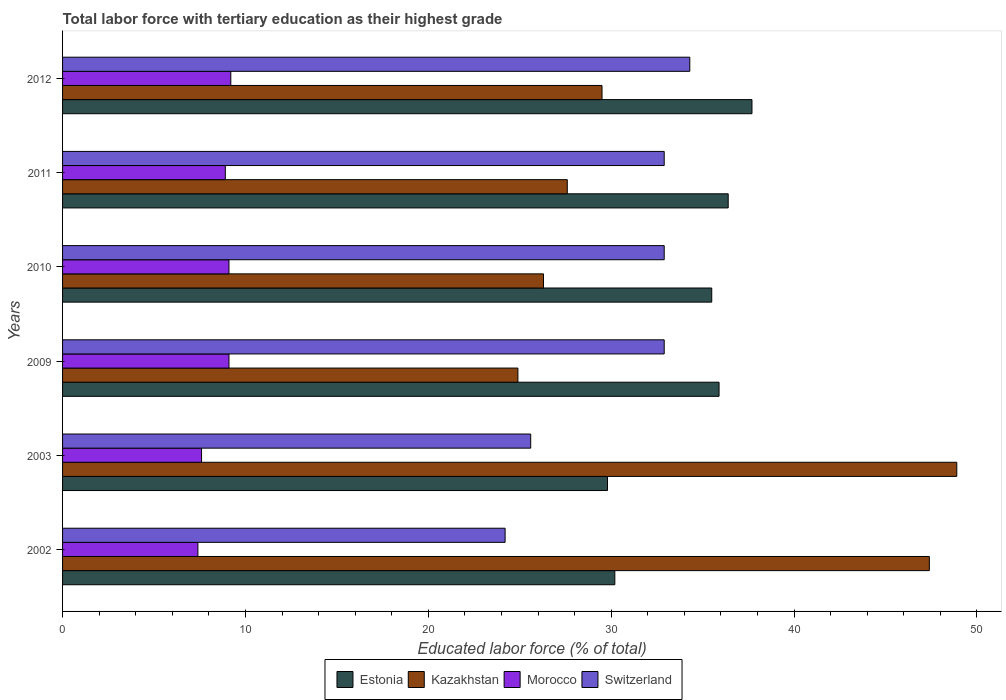Are the number of bars per tick equal to the number of legend labels?
Your answer should be very brief. Yes. How many bars are there on the 6th tick from the bottom?
Provide a short and direct response. 4. In how many cases, is the number of bars for a given year not equal to the number of legend labels?
Provide a succinct answer. 0. What is the percentage of male labor force with tertiary education in Estonia in 2012?
Provide a short and direct response. 37.7. Across all years, what is the maximum percentage of male labor force with tertiary education in Kazakhstan?
Your answer should be very brief. 48.9. Across all years, what is the minimum percentage of male labor force with tertiary education in Estonia?
Make the answer very short. 29.8. In which year was the percentage of male labor force with tertiary education in Switzerland maximum?
Provide a short and direct response. 2012. In which year was the percentage of male labor force with tertiary education in Estonia minimum?
Your answer should be very brief. 2003. What is the total percentage of male labor force with tertiary education in Morocco in the graph?
Offer a terse response. 51.3. What is the difference between the percentage of male labor force with tertiary education in Morocco in 2002 and that in 2009?
Your response must be concise. -1.7. What is the difference between the percentage of male labor force with tertiary education in Switzerland in 2009 and the percentage of male labor force with tertiary education in Morocco in 2012?
Ensure brevity in your answer.  23.7. What is the average percentage of male labor force with tertiary education in Morocco per year?
Keep it short and to the point. 8.55. In the year 2010, what is the difference between the percentage of male labor force with tertiary education in Estonia and percentage of male labor force with tertiary education in Kazakhstan?
Offer a terse response. 9.2. What is the ratio of the percentage of male labor force with tertiary education in Morocco in 2009 to that in 2011?
Keep it short and to the point. 1.02. What is the difference between the highest and the second highest percentage of male labor force with tertiary education in Switzerland?
Provide a succinct answer. 1.4. What is the difference between the highest and the lowest percentage of male labor force with tertiary education in Estonia?
Provide a short and direct response. 7.9. In how many years, is the percentage of male labor force with tertiary education in Switzerland greater than the average percentage of male labor force with tertiary education in Switzerland taken over all years?
Give a very brief answer. 4. What does the 3rd bar from the top in 2002 represents?
Make the answer very short. Kazakhstan. What does the 4th bar from the bottom in 2012 represents?
Give a very brief answer. Switzerland. How many bars are there?
Keep it short and to the point. 24. Are all the bars in the graph horizontal?
Give a very brief answer. Yes. What is the difference between two consecutive major ticks on the X-axis?
Offer a very short reply. 10. Are the values on the major ticks of X-axis written in scientific E-notation?
Provide a succinct answer. No. Does the graph contain grids?
Keep it short and to the point. No. How are the legend labels stacked?
Make the answer very short. Horizontal. What is the title of the graph?
Offer a terse response. Total labor force with tertiary education as their highest grade. What is the label or title of the X-axis?
Keep it short and to the point. Educated labor force (% of total). What is the label or title of the Y-axis?
Make the answer very short. Years. What is the Educated labor force (% of total) in Estonia in 2002?
Offer a terse response. 30.2. What is the Educated labor force (% of total) in Kazakhstan in 2002?
Your answer should be very brief. 47.4. What is the Educated labor force (% of total) in Morocco in 2002?
Provide a succinct answer. 7.4. What is the Educated labor force (% of total) of Switzerland in 2002?
Make the answer very short. 24.2. What is the Educated labor force (% of total) in Estonia in 2003?
Give a very brief answer. 29.8. What is the Educated labor force (% of total) of Kazakhstan in 2003?
Give a very brief answer. 48.9. What is the Educated labor force (% of total) of Morocco in 2003?
Make the answer very short. 7.6. What is the Educated labor force (% of total) of Switzerland in 2003?
Ensure brevity in your answer.  25.6. What is the Educated labor force (% of total) of Estonia in 2009?
Provide a succinct answer. 35.9. What is the Educated labor force (% of total) in Kazakhstan in 2009?
Provide a short and direct response. 24.9. What is the Educated labor force (% of total) in Morocco in 2009?
Give a very brief answer. 9.1. What is the Educated labor force (% of total) in Switzerland in 2009?
Give a very brief answer. 32.9. What is the Educated labor force (% of total) in Estonia in 2010?
Give a very brief answer. 35.5. What is the Educated labor force (% of total) of Kazakhstan in 2010?
Offer a very short reply. 26.3. What is the Educated labor force (% of total) in Morocco in 2010?
Give a very brief answer. 9.1. What is the Educated labor force (% of total) of Switzerland in 2010?
Offer a very short reply. 32.9. What is the Educated labor force (% of total) in Estonia in 2011?
Your answer should be very brief. 36.4. What is the Educated labor force (% of total) in Kazakhstan in 2011?
Your answer should be compact. 27.6. What is the Educated labor force (% of total) of Morocco in 2011?
Your answer should be compact. 8.9. What is the Educated labor force (% of total) of Switzerland in 2011?
Your answer should be compact. 32.9. What is the Educated labor force (% of total) of Estonia in 2012?
Keep it short and to the point. 37.7. What is the Educated labor force (% of total) in Kazakhstan in 2012?
Keep it short and to the point. 29.5. What is the Educated labor force (% of total) in Morocco in 2012?
Make the answer very short. 9.2. What is the Educated labor force (% of total) of Switzerland in 2012?
Give a very brief answer. 34.3. Across all years, what is the maximum Educated labor force (% of total) of Estonia?
Offer a very short reply. 37.7. Across all years, what is the maximum Educated labor force (% of total) of Kazakhstan?
Your answer should be very brief. 48.9. Across all years, what is the maximum Educated labor force (% of total) in Morocco?
Make the answer very short. 9.2. Across all years, what is the maximum Educated labor force (% of total) in Switzerland?
Your answer should be compact. 34.3. Across all years, what is the minimum Educated labor force (% of total) in Estonia?
Your answer should be very brief. 29.8. Across all years, what is the minimum Educated labor force (% of total) in Kazakhstan?
Offer a terse response. 24.9. Across all years, what is the minimum Educated labor force (% of total) in Morocco?
Keep it short and to the point. 7.4. Across all years, what is the minimum Educated labor force (% of total) of Switzerland?
Your answer should be compact. 24.2. What is the total Educated labor force (% of total) in Estonia in the graph?
Give a very brief answer. 205.5. What is the total Educated labor force (% of total) of Kazakhstan in the graph?
Your answer should be very brief. 204.6. What is the total Educated labor force (% of total) in Morocco in the graph?
Your answer should be compact. 51.3. What is the total Educated labor force (% of total) of Switzerland in the graph?
Your response must be concise. 182.8. What is the difference between the Educated labor force (% of total) in Estonia in 2002 and that in 2003?
Your answer should be compact. 0.4. What is the difference between the Educated labor force (% of total) of Kazakhstan in 2002 and that in 2003?
Provide a short and direct response. -1.5. What is the difference between the Educated labor force (% of total) of Kazakhstan in 2002 and that in 2009?
Provide a short and direct response. 22.5. What is the difference between the Educated labor force (% of total) of Estonia in 2002 and that in 2010?
Keep it short and to the point. -5.3. What is the difference between the Educated labor force (% of total) in Kazakhstan in 2002 and that in 2010?
Give a very brief answer. 21.1. What is the difference between the Educated labor force (% of total) in Kazakhstan in 2002 and that in 2011?
Your answer should be very brief. 19.8. What is the difference between the Educated labor force (% of total) of Estonia in 2002 and that in 2012?
Ensure brevity in your answer.  -7.5. What is the difference between the Educated labor force (% of total) in Kazakhstan in 2002 and that in 2012?
Ensure brevity in your answer.  17.9. What is the difference between the Educated labor force (% of total) of Estonia in 2003 and that in 2009?
Your answer should be very brief. -6.1. What is the difference between the Educated labor force (% of total) in Kazakhstan in 2003 and that in 2009?
Provide a succinct answer. 24. What is the difference between the Educated labor force (% of total) of Morocco in 2003 and that in 2009?
Provide a short and direct response. -1.5. What is the difference between the Educated labor force (% of total) in Estonia in 2003 and that in 2010?
Provide a short and direct response. -5.7. What is the difference between the Educated labor force (% of total) of Kazakhstan in 2003 and that in 2010?
Your answer should be very brief. 22.6. What is the difference between the Educated labor force (% of total) of Switzerland in 2003 and that in 2010?
Offer a terse response. -7.3. What is the difference between the Educated labor force (% of total) of Estonia in 2003 and that in 2011?
Offer a very short reply. -6.6. What is the difference between the Educated labor force (% of total) of Kazakhstan in 2003 and that in 2011?
Your answer should be compact. 21.3. What is the difference between the Educated labor force (% of total) in Morocco in 2003 and that in 2011?
Provide a short and direct response. -1.3. What is the difference between the Educated labor force (% of total) in Switzerland in 2003 and that in 2011?
Your answer should be compact. -7.3. What is the difference between the Educated labor force (% of total) of Kazakhstan in 2003 and that in 2012?
Your answer should be very brief. 19.4. What is the difference between the Educated labor force (% of total) of Morocco in 2003 and that in 2012?
Provide a short and direct response. -1.6. What is the difference between the Educated labor force (% of total) of Switzerland in 2003 and that in 2012?
Provide a succinct answer. -8.7. What is the difference between the Educated labor force (% of total) in Kazakhstan in 2009 and that in 2010?
Offer a very short reply. -1.4. What is the difference between the Educated labor force (% of total) of Estonia in 2009 and that in 2011?
Provide a short and direct response. -0.5. What is the difference between the Educated labor force (% of total) in Morocco in 2009 and that in 2011?
Keep it short and to the point. 0.2. What is the difference between the Educated labor force (% of total) in Kazakhstan in 2009 and that in 2012?
Offer a very short reply. -4.6. What is the difference between the Educated labor force (% of total) of Morocco in 2009 and that in 2012?
Make the answer very short. -0.1. What is the difference between the Educated labor force (% of total) of Switzerland in 2009 and that in 2012?
Ensure brevity in your answer.  -1.4. What is the difference between the Educated labor force (% of total) of Kazakhstan in 2010 and that in 2011?
Give a very brief answer. -1.3. What is the difference between the Educated labor force (% of total) of Switzerland in 2010 and that in 2011?
Provide a succinct answer. 0. What is the difference between the Educated labor force (% of total) in Switzerland in 2010 and that in 2012?
Keep it short and to the point. -1.4. What is the difference between the Educated labor force (% of total) of Estonia in 2011 and that in 2012?
Provide a succinct answer. -1.3. What is the difference between the Educated labor force (% of total) of Kazakhstan in 2011 and that in 2012?
Give a very brief answer. -1.9. What is the difference between the Educated labor force (% of total) of Morocco in 2011 and that in 2012?
Provide a succinct answer. -0.3. What is the difference between the Educated labor force (% of total) of Estonia in 2002 and the Educated labor force (% of total) of Kazakhstan in 2003?
Provide a short and direct response. -18.7. What is the difference between the Educated labor force (% of total) in Estonia in 2002 and the Educated labor force (% of total) in Morocco in 2003?
Your answer should be compact. 22.6. What is the difference between the Educated labor force (% of total) of Kazakhstan in 2002 and the Educated labor force (% of total) of Morocco in 2003?
Offer a very short reply. 39.8. What is the difference between the Educated labor force (% of total) of Kazakhstan in 2002 and the Educated labor force (% of total) of Switzerland in 2003?
Keep it short and to the point. 21.8. What is the difference between the Educated labor force (% of total) in Morocco in 2002 and the Educated labor force (% of total) in Switzerland in 2003?
Provide a succinct answer. -18.2. What is the difference between the Educated labor force (% of total) in Estonia in 2002 and the Educated labor force (% of total) in Kazakhstan in 2009?
Your response must be concise. 5.3. What is the difference between the Educated labor force (% of total) in Estonia in 2002 and the Educated labor force (% of total) in Morocco in 2009?
Provide a succinct answer. 21.1. What is the difference between the Educated labor force (% of total) of Estonia in 2002 and the Educated labor force (% of total) of Switzerland in 2009?
Your answer should be compact. -2.7. What is the difference between the Educated labor force (% of total) in Kazakhstan in 2002 and the Educated labor force (% of total) in Morocco in 2009?
Give a very brief answer. 38.3. What is the difference between the Educated labor force (% of total) of Kazakhstan in 2002 and the Educated labor force (% of total) of Switzerland in 2009?
Ensure brevity in your answer.  14.5. What is the difference between the Educated labor force (% of total) of Morocco in 2002 and the Educated labor force (% of total) of Switzerland in 2009?
Ensure brevity in your answer.  -25.5. What is the difference between the Educated labor force (% of total) in Estonia in 2002 and the Educated labor force (% of total) in Morocco in 2010?
Your response must be concise. 21.1. What is the difference between the Educated labor force (% of total) in Kazakhstan in 2002 and the Educated labor force (% of total) in Morocco in 2010?
Give a very brief answer. 38.3. What is the difference between the Educated labor force (% of total) of Morocco in 2002 and the Educated labor force (% of total) of Switzerland in 2010?
Offer a terse response. -25.5. What is the difference between the Educated labor force (% of total) of Estonia in 2002 and the Educated labor force (% of total) of Kazakhstan in 2011?
Give a very brief answer. 2.6. What is the difference between the Educated labor force (% of total) of Estonia in 2002 and the Educated labor force (% of total) of Morocco in 2011?
Provide a short and direct response. 21.3. What is the difference between the Educated labor force (% of total) of Estonia in 2002 and the Educated labor force (% of total) of Switzerland in 2011?
Offer a very short reply. -2.7. What is the difference between the Educated labor force (% of total) in Kazakhstan in 2002 and the Educated labor force (% of total) in Morocco in 2011?
Provide a succinct answer. 38.5. What is the difference between the Educated labor force (% of total) of Kazakhstan in 2002 and the Educated labor force (% of total) of Switzerland in 2011?
Keep it short and to the point. 14.5. What is the difference between the Educated labor force (% of total) in Morocco in 2002 and the Educated labor force (% of total) in Switzerland in 2011?
Give a very brief answer. -25.5. What is the difference between the Educated labor force (% of total) of Estonia in 2002 and the Educated labor force (% of total) of Switzerland in 2012?
Give a very brief answer. -4.1. What is the difference between the Educated labor force (% of total) of Kazakhstan in 2002 and the Educated labor force (% of total) of Morocco in 2012?
Provide a short and direct response. 38.2. What is the difference between the Educated labor force (% of total) of Morocco in 2002 and the Educated labor force (% of total) of Switzerland in 2012?
Keep it short and to the point. -26.9. What is the difference between the Educated labor force (% of total) of Estonia in 2003 and the Educated labor force (% of total) of Morocco in 2009?
Your answer should be compact. 20.7. What is the difference between the Educated labor force (% of total) in Estonia in 2003 and the Educated labor force (% of total) in Switzerland in 2009?
Your answer should be compact. -3.1. What is the difference between the Educated labor force (% of total) of Kazakhstan in 2003 and the Educated labor force (% of total) of Morocco in 2009?
Offer a terse response. 39.8. What is the difference between the Educated labor force (% of total) in Kazakhstan in 2003 and the Educated labor force (% of total) in Switzerland in 2009?
Ensure brevity in your answer.  16. What is the difference between the Educated labor force (% of total) in Morocco in 2003 and the Educated labor force (% of total) in Switzerland in 2009?
Your response must be concise. -25.3. What is the difference between the Educated labor force (% of total) of Estonia in 2003 and the Educated labor force (% of total) of Kazakhstan in 2010?
Provide a short and direct response. 3.5. What is the difference between the Educated labor force (% of total) in Estonia in 2003 and the Educated labor force (% of total) in Morocco in 2010?
Offer a terse response. 20.7. What is the difference between the Educated labor force (% of total) in Kazakhstan in 2003 and the Educated labor force (% of total) in Morocco in 2010?
Keep it short and to the point. 39.8. What is the difference between the Educated labor force (% of total) of Kazakhstan in 2003 and the Educated labor force (% of total) of Switzerland in 2010?
Ensure brevity in your answer.  16. What is the difference between the Educated labor force (% of total) of Morocco in 2003 and the Educated labor force (% of total) of Switzerland in 2010?
Keep it short and to the point. -25.3. What is the difference between the Educated labor force (% of total) in Estonia in 2003 and the Educated labor force (% of total) in Kazakhstan in 2011?
Keep it short and to the point. 2.2. What is the difference between the Educated labor force (% of total) in Estonia in 2003 and the Educated labor force (% of total) in Morocco in 2011?
Give a very brief answer. 20.9. What is the difference between the Educated labor force (% of total) of Estonia in 2003 and the Educated labor force (% of total) of Switzerland in 2011?
Offer a very short reply. -3.1. What is the difference between the Educated labor force (% of total) of Kazakhstan in 2003 and the Educated labor force (% of total) of Morocco in 2011?
Your response must be concise. 40. What is the difference between the Educated labor force (% of total) of Kazakhstan in 2003 and the Educated labor force (% of total) of Switzerland in 2011?
Your answer should be very brief. 16. What is the difference between the Educated labor force (% of total) of Morocco in 2003 and the Educated labor force (% of total) of Switzerland in 2011?
Your response must be concise. -25.3. What is the difference between the Educated labor force (% of total) of Estonia in 2003 and the Educated labor force (% of total) of Kazakhstan in 2012?
Offer a very short reply. 0.3. What is the difference between the Educated labor force (% of total) of Estonia in 2003 and the Educated labor force (% of total) of Morocco in 2012?
Provide a short and direct response. 20.6. What is the difference between the Educated labor force (% of total) in Kazakhstan in 2003 and the Educated labor force (% of total) in Morocco in 2012?
Provide a succinct answer. 39.7. What is the difference between the Educated labor force (% of total) in Morocco in 2003 and the Educated labor force (% of total) in Switzerland in 2012?
Ensure brevity in your answer.  -26.7. What is the difference between the Educated labor force (% of total) of Estonia in 2009 and the Educated labor force (% of total) of Morocco in 2010?
Offer a very short reply. 26.8. What is the difference between the Educated labor force (% of total) of Kazakhstan in 2009 and the Educated labor force (% of total) of Switzerland in 2010?
Your answer should be very brief. -8. What is the difference between the Educated labor force (% of total) in Morocco in 2009 and the Educated labor force (% of total) in Switzerland in 2010?
Offer a very short reply. -23.8. What is the difference between the Educated labor force (% of total) of Estonia in 2009 and the Educated labor force (% of total) of Morocco in 2011?
Make the answer very short. 27. What is the difference between the Educated labor force (% of total) in Estonia in 2009 and the Educated labor force (% of total) in Switzerland in 2011?
Make the answer very short. 3. What is the difference between the Educated labor force (% of total) in Morocco in 2009 and the Educated labor force (% of total) in Switzerland in 2011?
Your response must be concise. -23.8. What is the difference between the Educated labor force (% of total) in Estonia in 2009 and the Educated labor force (% of total) in Morocco in 2012?
Provide a short and direct response. 26.7. What is the difference between the Educated labor force (% of total) of Kazakhstan in 2009 and the Educated labor force (% of total) of Switzerland in 2012?
Make the answer very short. -9.4. What is the difference between the Educated labor force (% of total) in Morocco in 2009 and the Educated labor force (% of total) in Switzerland in 2012?
Ensure brevity in your answer.  -25.2. What is the difference between the Educated labor force (% of total) of Estonia in 2010 and the Educated labor force (% of total) of Morocco in 2011?
Your answer should be very brief. 26.6. What is the difference between the Educated labor force (% of total) in Kazakhstan in 2010 and the Educated labor force (% of total) in Morocco in 2011?
Make the answer very short. 17.4. What is the difference between the Educated labor force (% of total) in Morocco in 2010 and the Educated labor force (% of total) in Switzerland in 2011?
Keep it short and to the point. -23.8. What is the difference between the Educated labor force (% of total) of Estonia in 2010 and the Educated labor force (% of total) of Kazakhstan in 2012?
Provide a succinct answer. 6. What is the difference between the Educated labor force (% of total) in Estonia in 2010 and the Educated labor force (% of total) in Morocco in 2012?
Give a very brief answer. 26.3. What is the difference between the Educated labor force (% of total) of Estonia in 2010 and the Educated labor force (% of total) of Switzerland in 2012?
Your answer should be very brief. 1.2. What is the difference between the Educated labor force (% of total) in Kazakhstan in 2010 and the Educated labor force (% of total) in Morocco in 2012?
Your response must be concise. 17.1. What is the difference between the Educated labor force (% of total) in Morocco in 2010 and the Educated labor force (% of total) in Switzerland in 2012?
Give a very brief answer. -25.2. What is the difference between the Educated labor force (% of total) in Estonia in 2011 and the Educated labor force (% of total) in Morocco in 2012?
Your answer should be compact. 27.2. What is the difference between the Educated labor force (% of total) of Kazakhstan in 2011 and the Educated labor force (% of total) of Morocco in 2012?
Offer a very short reply. 18.4. What is the difference between the Educated labor force (% of total) of Kazakhstan in 2011 and the Educated labor force (% of total) of Switzerland in 2012?
Your answer should be very brief. -6.7. What is the difference between the Educated labor force (% of total) of Morocco in 2011 and the Educated labor force (% of total) of Switzerland in 2012?
Provide a succinct answer. -25.4. What is the average Educated labor force (% of total) of Estonia per year?
Provide a short and direct response. 34.25. What is the average Educated labor force (% of total) of Kazakhstan per year?
Give a very brief answer. 34.1. What is the average Educated labor force (% of total) of Morocco per year?
Ensure brevity in your answer.  8.55. What is the average Educated labor force (% of total) of Switzerland per year?
Your response must be concise. 30.47. In the year 2002, what is the difference between the Educated labor force (% of total) in Estonia and Educated labor force (% of total) in Kazakhstan?
Ensure brevity in your answer.  -17.2. In the year 2002, what is the difference between the Educated labor force (% of total) of Estonia and Educated labor force (% of total) of Morocco?
Provide a short and direct response. 22.8. In the year 2002, what is the difference between the Educated labor force (% of total) in Estonia and Educated labor force (% of total) in Switzerland?
Keep it short and to the point. 6. In the year 2002, what is the difference between the Educated labor force (% of total) of Kazakhstan and Educated labor force (% of total) of Switzerland?
Keep it short and to the point. 23.2. In the year 2002, what is the difference between the Educated labor force (% of total) of Morocco and Educated labor force (% of total) of Switzerland?
Your answer should be very brief. -16.8. In the year 2003, what is the difference between the Educated labor force (% of total) in Estonia and Educated labor force (% of total) in Kazakhstan?
Offer a terse response. -19.1. In the year 2003, what is the difference between the Educated labor force (% of total) of Estonia and Educated labor force (% of total) of Morocco?
Your answer should be compact. 22.2. In the year 2003, what is the difference between the Educated labor force (% of total) in Estonia and Educated labor force (% of total) in Switzerland?
Keep it short and to the point. 4.2. In the year 2003, what is the difference between the Educated labor force (% of total) of Kazakhstan and Educated labor force (% of total) of Morocco?
Your answer should be compact. 41.3. In the year 2003, what is the difference between the Educated labor force (% of total) in Kazakhstan and Educated labor force (% of total) in Switzerland?
Give a very brief answer. 23.3. In the year 2009, what is the difference between the Educated labor force (% of total) in Estonia and Educated labor force (% of total) in Morocco?
Your response must be concise. 26.8. In the year 2009, what is the difference between the Educated labor force (% of total) in Kazakhstan and Educated labor force (% of total) in Switzerland?
Your answer should be very brief. -8. In the year 2009, what is the difference between the Educated labor force (% of total) of Morocco and Educated labor force (% of total) of Switzerland?
Make the answer very short. -23.8. In the year 2010, what is the difference between the Educated labor force (% of total) in Estonia and Educated labor force (% of total) in Kazakhstan?
Keep it short and to the point. 9.2. In the year 2010, what is the difference between the Educated labor force (% of total) in Estonia and Educated labor force (% of total) in Morocco?
Make the answer very short. 26.4. In the year 2010, what is the difference between the Educated labor force (% of total) in Estonia and Educated labor force (% of total) in Switzerland?
Give a very brief answer. 2.6. In the year 2010, what is the difference between the Educated labor force (% of total) in Kazakhstan and Educated labor force (% of total) in Morocco?
Make the answer very short. 17.2. In the year 2010, what is the difference between the Educated labor force (% of total) in Kazakhstan and Educated labor force (% of total) in Switzerland?
Ensure brevity in your answer.  -6.6. In the year 2010, what is the difference between the Educated labor force (% of total) of Morocco and Educated labor force (% of total) of Switzerland?
Your answer should be compact. -23.8. In the year 2011, what is the difference between the Educated labor force (% of total) in Morocco and Educated labor force (% of total) in Switzerland?
Your response must be concise. -24. In the year 2012, what is the difference between the Educated labor force (% of total) in Estonia and Educated labor force (% of total) in Kazakhstan?
Your response must be concise. 8.2. In the year 2012, what is the difference between the Educated labor force (% of total) in Estonia and Educated labor force (% of total) in Morocco?
Provide a succinct answer. 28.5. In the year 2012, what is the difference between the Educated labor force (% of total) in Kazakhstan and Educated labor force (% of total) in Morocco?
Offer a very short reply. 20.3. In the year 2012, what is the difference between the Educated labor force (% of total) in Kazakhstan and Educated labor force (% of total) in Switzerland?
Provide a short and direct response. -4.8. In the year 2012, what is the difference between the Educated labor force (% of total) in Morocco and Educated labor force (% of total) in Switzerland?
Your answer should be very brief. -25.1. What is the ratio of the Educated labor force (% of total) of Estonia in 2002 to that in 2003?
Make the answer very short. 1.01. What is the ratio of the Educated labor force (% of total) in Kazakhstan in 2002 to that in 2003?
Offer a very short reply. 0.97. What is the ratio of the Educated labor force (% of total) in Morocco in 2002 to that in 2003?
Offer a terse response. 0.97. What is the ratio of the Educated labor force (% of total) in Switzerland in 2002 to that in 2003?
Your answer should be very brief. 0.95. What is the ratio of the Educated labor force (% of total) in Estonia in 2002 to that in 2009?
Give a very brief answer. 0.84. What is the ratio of the Educated labor force (% of total) of Kazakhstan in 2002 to that in 2009?
Ensure brevity in your answer.  1.9. What is the ratio of the Educated labor force (% of total) of Morocco in 2002 to that in 2009?
Offer a terse response. 0.81. What is the ratio of the Educated labor force (% of total) of Switzerland in 2002 to that in 2009?
Give a very brief answer. 0.74. What is the ratio of the Educated labor force (% of total) in Estonia in 2002 to that in 2010?
Ensure brevity in your answer.  0.85. What is the ratio of the Educated labor force (% of total) in Kazakhstan in 2002 to that in 2010?
Keep it short and to the point. 1.8. What is the ratio of the Educated labor force (% of total) in Morocco in 2002 to that in 2010?
Provide a short and direct response. 0.81. What is the ratio of the Educated labor force (% of total) in Switzerland in 2002 to that in 2010?
Provide a short and direct response. 0.74. What is the ratio of the Educated labor force (% of total) of Estonia in 2002 to that in 2011?
Your response must be concise. 0.83. What is the ratio of the Educated labor force (% of total) in Kazakhstan in 2002 to that in 2011?
Offer a very short reply. 1.72. What is the ratio of the Educated labor force (% of total) in Morocco in 2002 to that in 2011?
Offer a very short reply. 0.83. What is the ratio of the Educated labor force (% of total) in Switzerland in 2002 to that in 2011?
Keep it short and to the point. 0.74. What is the ratio of the Educated labor force (% of total) in Estonia in 2002 to that in 2012?
Offer a very short reply. 0.8. What is the ratio of the Educated labor force (% of total) in Kazakhstan in 2002 to that in 2012?
Provide a short and direct response. 1.61. What is the ratio of the Educated labor force (% of total) in Morocco in 2002 to that in 2012?
Your answer should be compact. 0.8. What is the ratio of the Educated labor force (% of total) in Switzerland in 2002 to that in 2012?
Offer a very short reply. 0.71. What is the ratio of the Educated labor force (% of total) in Estonia in 2003 to that in 2009?
Offer a very short reply. 0.83. What is the ratio of the Educated labor force (% of total) of Kazakhstan in 2003 to that in 2009?
Provide a short and direct response. 1.96. What is the ratio of the Educated labor force (% of total) of Morocco in 2003 to that in 2009?
Offer a very short reply. 0.84. What is the ratio of the Educated labor force (% of total) of Switzerland in 2003 to that in 2009?
Give a very brief answer. 0.78. What is the ratio of the Educated labor force (% of total) in Estonia in 2003 to that in 2010?
Offer a very short reply. 0.84. What is the ratio of the Educated labor force (% of total) of Kazakhstan in 2003 to that in 2010?
Ensure brevity in your answer.  1.86. What is the ratio of the Educated labor force (% of total) of Morocco in 2003 to that in 2010?
Make the answer very short. 0.84. What is the ratio of the Educated labor force (% of total) in Switzerland in 2003 to that in 2010?
Keep it short and to the point. 0.78. What is the ratio of the Educated labor force (% of total) of Estonia in 2003 to that in 2011?
Offer a terse response. 0.82. What is the ratio of the Educated labor force (% of total) of Kazakhstan in 2003 to that in 2011?
Make the answer very short. 1.77. What is the ratio of the Educated labor force (% of total) in Morocco in 2003 to that in 2011?
Your answer should be very brief. 0.85. What is the ratio of the Educated labor force (% of total) in Switzerland in 2003 to that in 2011?
Your answer should be very brief. 0.78. What is the ratio of the Educated labor force (% of total) in Estonia in 2003 to that in 2012?
Keep it short and to the point. 0.79. What is the ratio of the Educated labor force (% of total) of Kazakhstan in 2003 to that in 2012?
Provide a succinct answer. 1.66. What is the ratio of the Educated labor force (% of total) in Morocco in 2003 to that in 2012?
Offer a terse response. 0.83. What is the ratio of the Educated labor force (% of total) of Switzerland in 2003 to that in 2012?
Your response must be concise. 0.75. What is the ratio of the Educated labor force (% of total) in Estonia in 2009 to that in 2010?
Offer a very short reply. 1.01. What is the ratio of the Educated labor force (% of total) in Kazakhstan in 2009 to that in 2010?
Provide a short and direct response. 0.95. What is the ratio of the Educated labor force (% of total) of Switzerland in 2009 to that in 2010?
Provide a short and direct response. 1. What is the ratio of the Educated labor force (% of total) of Estonia in 2009 to that in 2011?
Offer a terse response. 0.99. What is the ratio of the Educated labor force (% of total) of Kazakhstan in 2009 to that in 2011?
Ensure brevity in your answer.  0.9. What is the ratio of the Educated labor force (% of total) in Morocco in 2009 to that in 2011?
Keep it short and to the point. 1.02. What is the ratio of the Educated labor force (% of total) of Switzerland in 2009 to that in 2011?
Provide a short and direct response. 1. What is the ratio of the Educated labor force (% of total) in Estonia in 2009 to that in 2012?
Make the answer very short. 0.95. What is the ratio of the Educated labor force (% of total) in Kazakhstan in 2009 to that in 2012?
Provide a succinct answer. 0.84. What is the ratio of the Educated labor force (% of total) of Switzerland in 2009 to that in 2012?
Keep it short and to the point. 0.96. What is the ratio of the Educated labor force (% of total) of Estonia in 2010 to that in 2011?
Provide a short and direct response. 0.98. What is the ratio of the Educated labor force (% of total) in Kazakhstan in 2010 to that in 2011?
Keep it short and to the point. 0.95. What is the ratio of the Educated labor force (% of total) in Morocco in 2010 to that in 2011?
Your response must be concise. 1.02. What is the ratio of the Educated labor force (% of total) of Estonia in 2010 to that in 2012?
Offer a very short reply. 0.94. What is the ratio of the Educated labor force (% of total) in Kazakhstan in 2010 to that in 2012?
Your answer should be very brief. 0.89. What is the ratio of the Educated labor force (% of total) in Morocco in 2010 to that in 2012?
Give a very brief answer. 0.99. What is the ratio of the Educated labor force (% of total) in Switzerland in 2010 to that in 2012?
Your response must be concise. 0.96. What is the ratio of the Educated labor force (% of total) in Estonia in 2011 to that in 2012?
Make the answer very short. 0.97. What is the ratio of the Educated labor force (% of total) in Kazakhstan in 2011 to that in 2012?
Provide a short and direct response. 0.94. What is the ratio of the Educated labor force (% of total) in Morocco in 2011 to that in 2012?
Provide a succinct answer. 0.97. What is the ratio of the Educated labor force (% of total) in Switzerland in 2011 to that in 2012?
Offer a terse response. 0.96. What is the difference between the highest and the second highest Educated labor force (% of total) in Kazakhstan?
Offer a very short reply. 1.5. What is the difference between the highest and the second highest Educated labor force (% of total) in Switzerland?
Offer a very short reply. 1.4. 